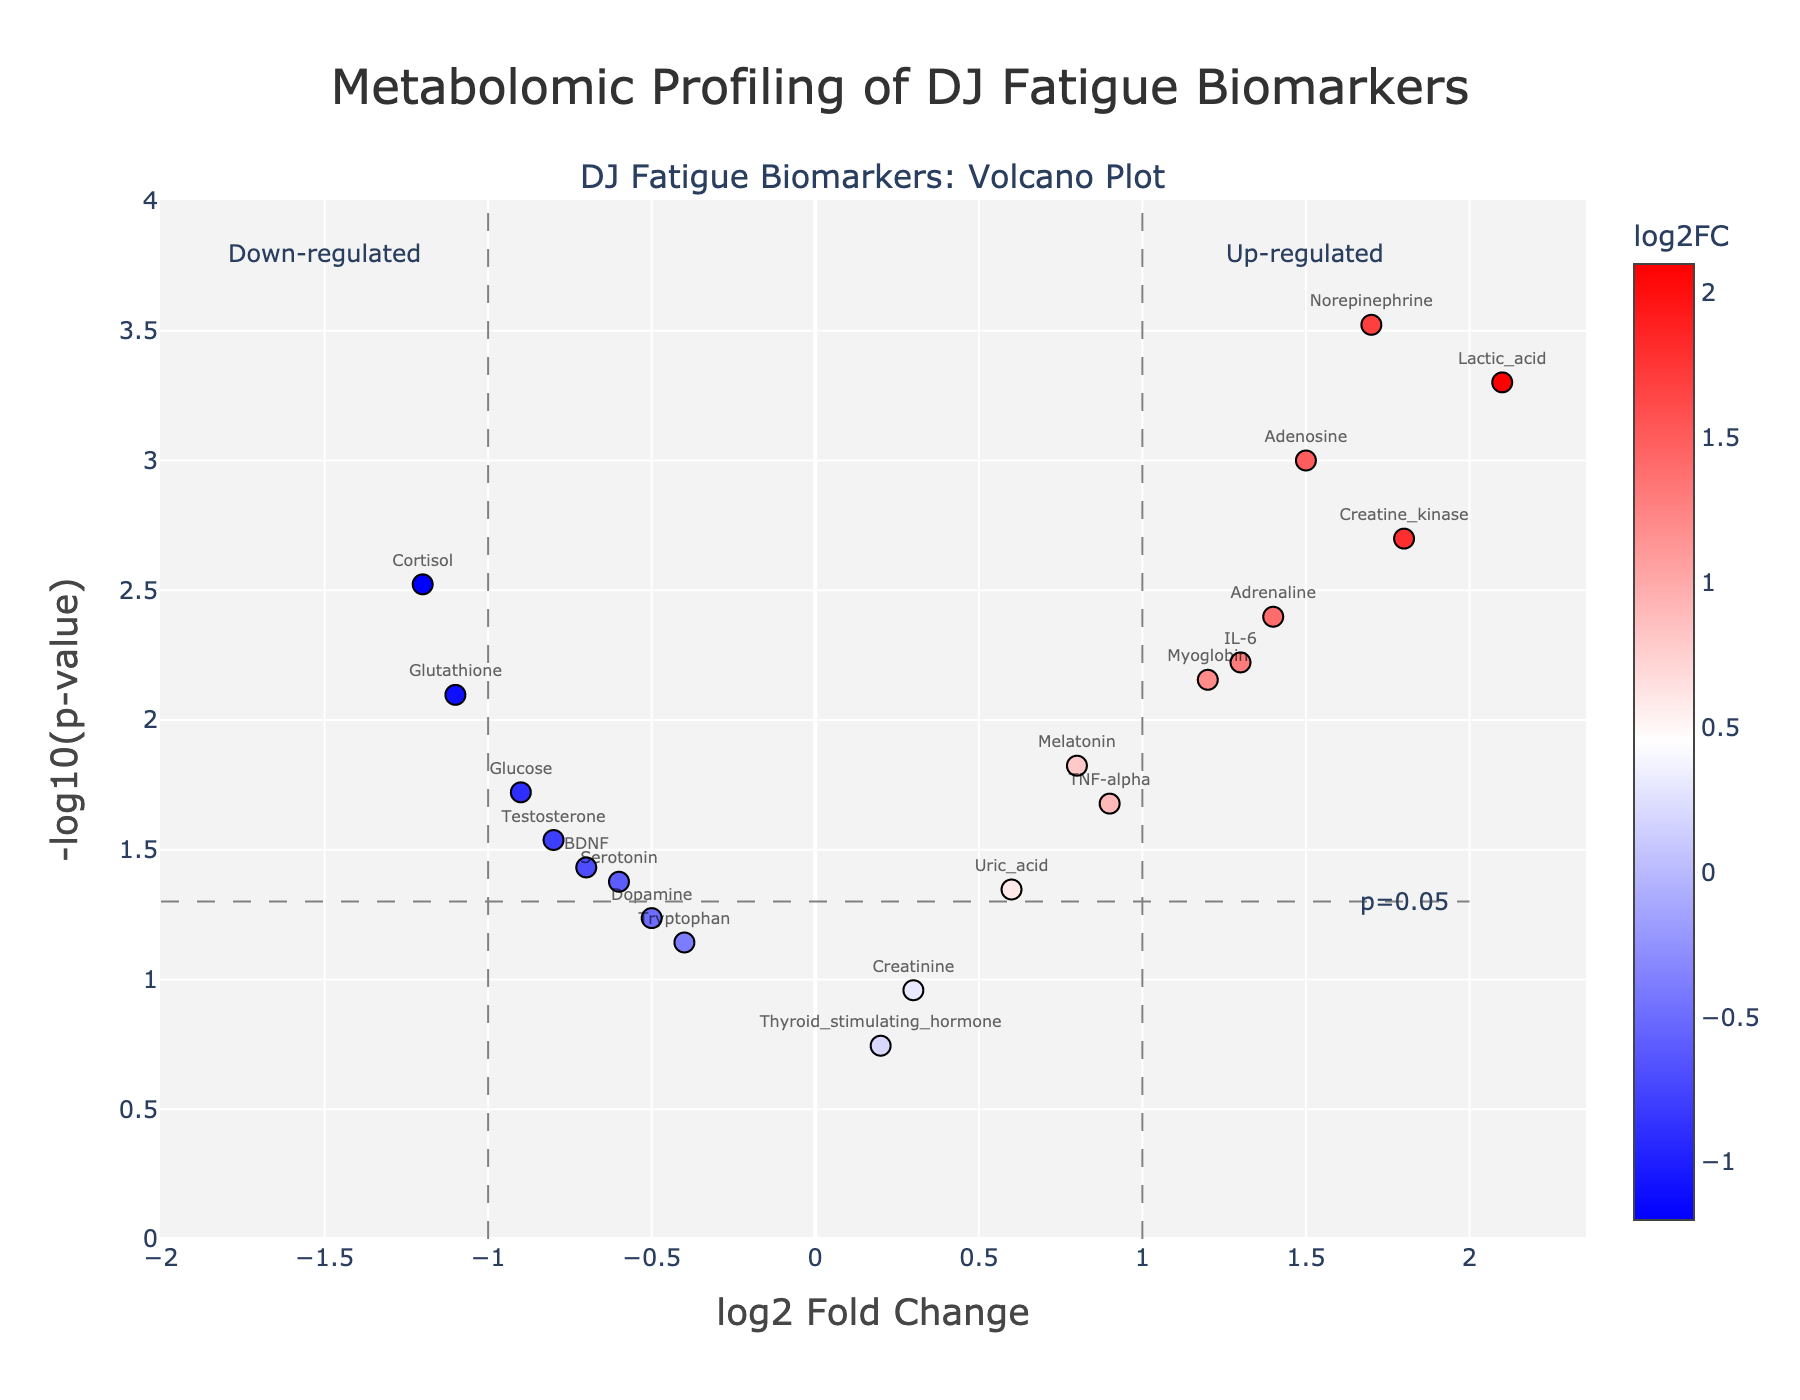1. What is the title of the plot? The title of the plot is displayed prominently at the top center. It is written in a larger font size and uses descriptive terms related to the content shown in the plot.
Answer: Metabolomic Profiling of DJ Fatigue Biomarkers 2. How many biomarkers are upregulated significantly (p < 0.05)? To determine the number of significantly upregulated biomarkers, examine the data points on the right side of the vertical line at log2 Fold Change = 1 and above the horizontal threshold line of -log10(p-value) = 1.3010. Count these points manually.
Answer: 6 3. Which biomarker has the highest log2 fold change? The highest log2 fold change can be found by locating the biomarker point farthest to the right on the x-axis.
Answer: Lactic_acid 4. What is the log2 fold change and p-value for cortisol? Locate the point labeled 'Cortisol' on the plot. The log2 fold change is the x-coordinate, and the p-value can be read from the hover text or converted from its -log10(p-value) y-coordinate.
Answer: log2FC: -1.2, p-value: 0.003 5. Among those with a p-value < 0.01, which biomarker is downregulated the most? Identify biomarkers below the significance threshold line (-log10(p-value) > 2) and look at negative log2 Fold Change values to find the one with the highest negative value.
Answer: Cortisol 6. How does the log2 fold change of creatine kinase compare to that of myoglobin? Locate the points labeled 'Creatine_kinase' and 'Myoglobin.' Compare their positions along the x-axis to determine which is higher or lower.
Answer: Creatine kinase is higher 7. What is the purpose of the dashed lines in the plot? The vertical dashed lines are located at log2 Fold Change = ±1 and the horizontal dashed line is at -log10(p-value) = 1.3010 (p = 0.05). These lines indicate thresholds for significant upregulation/downregulation and p-value cut-off.
Answer: Significance thresholds 8. Is serotonin significantly affected before and after performance sessions? Check the p-value for serotonin by looking at its position relative to the horizontal significance line or by reading the hover text. p-value < 0.05 indicates significance.
Answer: Yes 9. Which biomarker is closest to the significance threshold (log2 Fold Change threshold =1 or p-value threshold =0.05) but not deemed upregulated or downregulated? Locate the biomarkers near the threshold lines but not surpassing them. Check positions carefully to find the closest without crossing.
Answer: Dopamine 10. How many biomarkers have a negative log2 fold change but are not statistically significant (p-value > 0.05)? Look at the left side of log2 Fold Change = 0 (negative values) and under the horizontal line representing p < 0.05 to count these points.
Answer: 2 